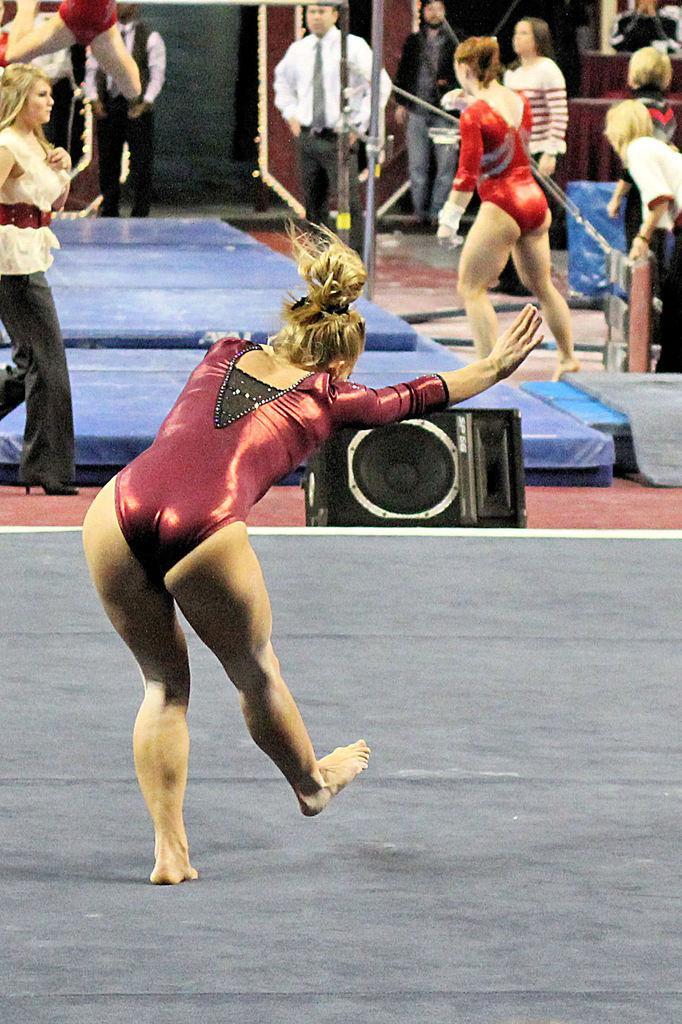Please provide a concise description of this image. Here I can see a woman standing on the floor facing towards the back side. It seems like she is doing an exercise. In the background there are many people standing and few people are walking. In the middle of the image there is a speaker placed on the ground and also there is a pole. 